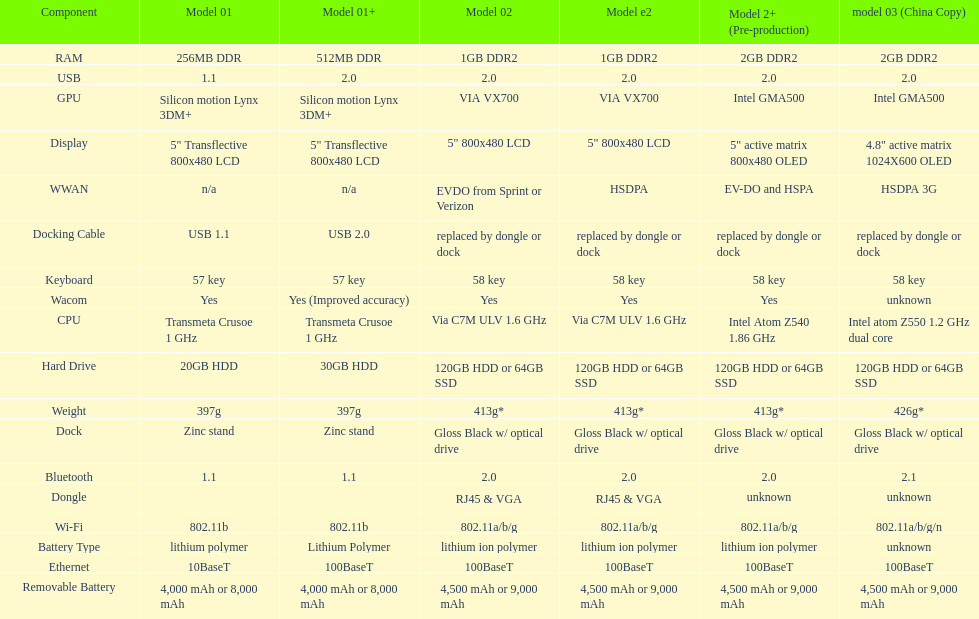What is the component before usb? Display. 